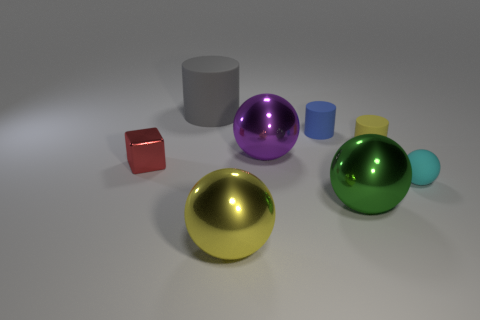Subtract all tiny matte cylinders. How many cylinders are left? 1 Subtract 1 balls. How many balls are left? 3 Subtract all yellow spheres. How many spheres are left? 3 Add 1 big balls. How many objects exist? 9 Subtract all gray spheres. Subtract all blue cylinders. How many spheres are left? 4 Subtract all cubes. How many objects are left? 7 Subtract all tiny rubber things. Subtract all red metallic objects. How many objects are left? 4 Add 8 small spheres. How many small spheres are left? 9 Add 8 large red matte cubes. How many large red matte cubes exist? 8 Subtract 1 red cubes. How many objects are left? 7 